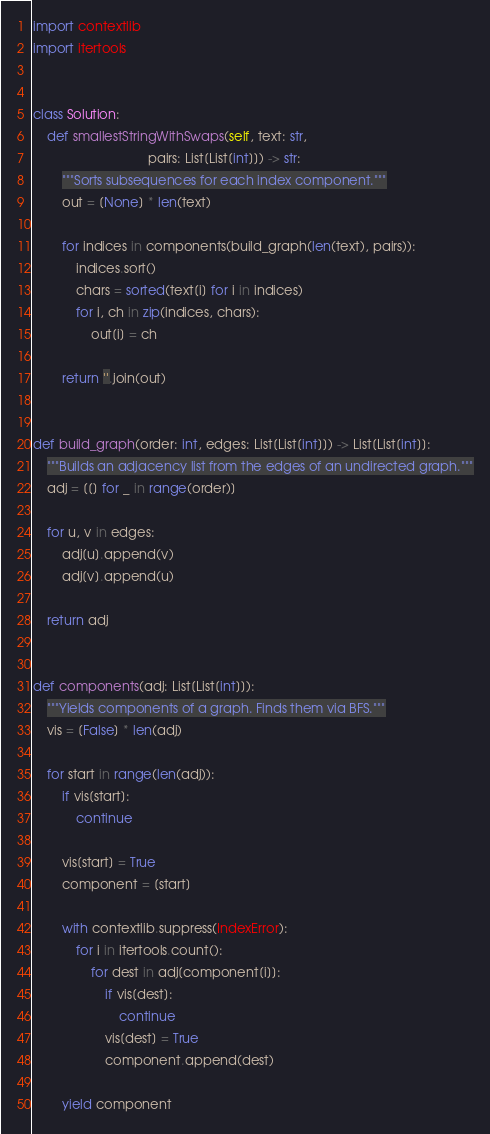<code> <loc_0><loc_0><loc_500><loc_500><_Python_>import contextlib
import itertools


class Solution:
    def smallestStringWithSwaps(self, text: str,
                                pairs: List[List[int]]) -> str:
        """Sorts subsequences for each index component."""
        out = [None] * len(text)

        for indices in components(build_graph(len(text), pairs)):
            indices.sort()
            chars = sorted(text[i] for i in indices)
            for i, ch in zip(indices, chars):
                out[i] = ch

        return ''.join(out)


def build_graph(order: int, edges: List[List[int]]) -> List[List[int]]:
    """Builds an adjacency list from the edges of an undirected graph."""
    adj = [[] for _ in range(order)]

    for u, v in edges:
        adj[u].append(v)
        adj[v].append(u)

    return adj


def components(adj: List[List[int]]):
    """Yields components of a graph. Finds them via BFS."""
    vis = [False] * len(adj)

    for start in range(len(adj)):
        if vis[start]:
            continue

        vis[start] = True
        component = [start]

        with contextlib.suppress(IndexError):
            for i in itertools.count():
                for dest in adj[component[i]]:
                    if vis[dest]:
                        continue
                    vis[dest] = True
                    component.append(dest)

        yield component
</code> 